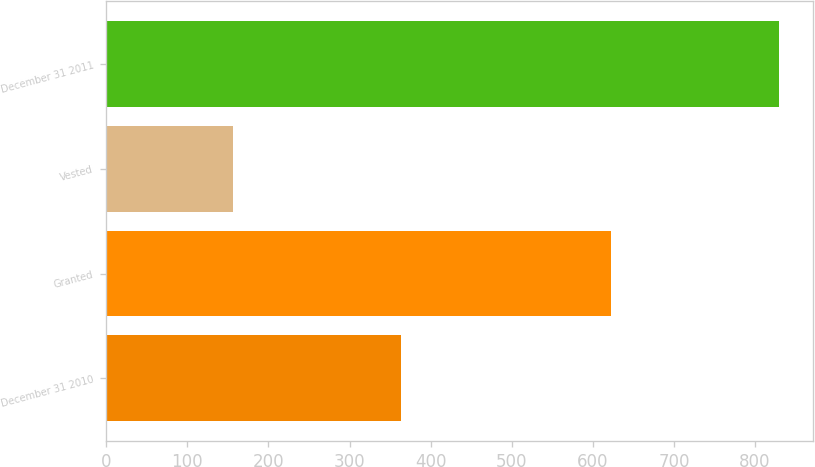Convert chart to OTSL. <chart><loc_0><loc_0><loc_500><loc_500><bar_chart><fcel>December 31 2010<fcel>Granted<fcel>Vested<fcel>December 31 2011<nl><fcel>363<fcel>623<fcel>156<fcel>830<nl></chart> 